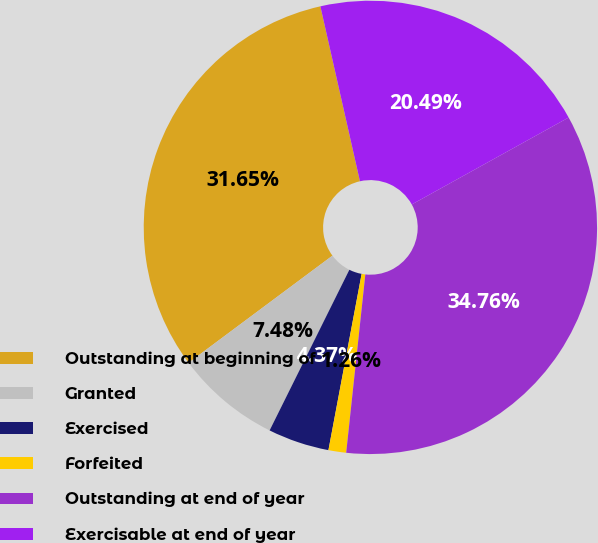Convert chart to OTSL. <chart><loc_0><loc_0><loc_500><loc_500><pie_chart><fcel>Outstanding at beginning of<fcel>Granted<fcel>Exercised<fcel>Forfeited<fcel>Outstanding at end of year<fcel>Exercisable at end of year<nl><fcel>31.65%<fcel>7.48%<fcel>4.37%<fcel>1.26%<fcel>34.76%<fcel>20.49%<nl></chart> 